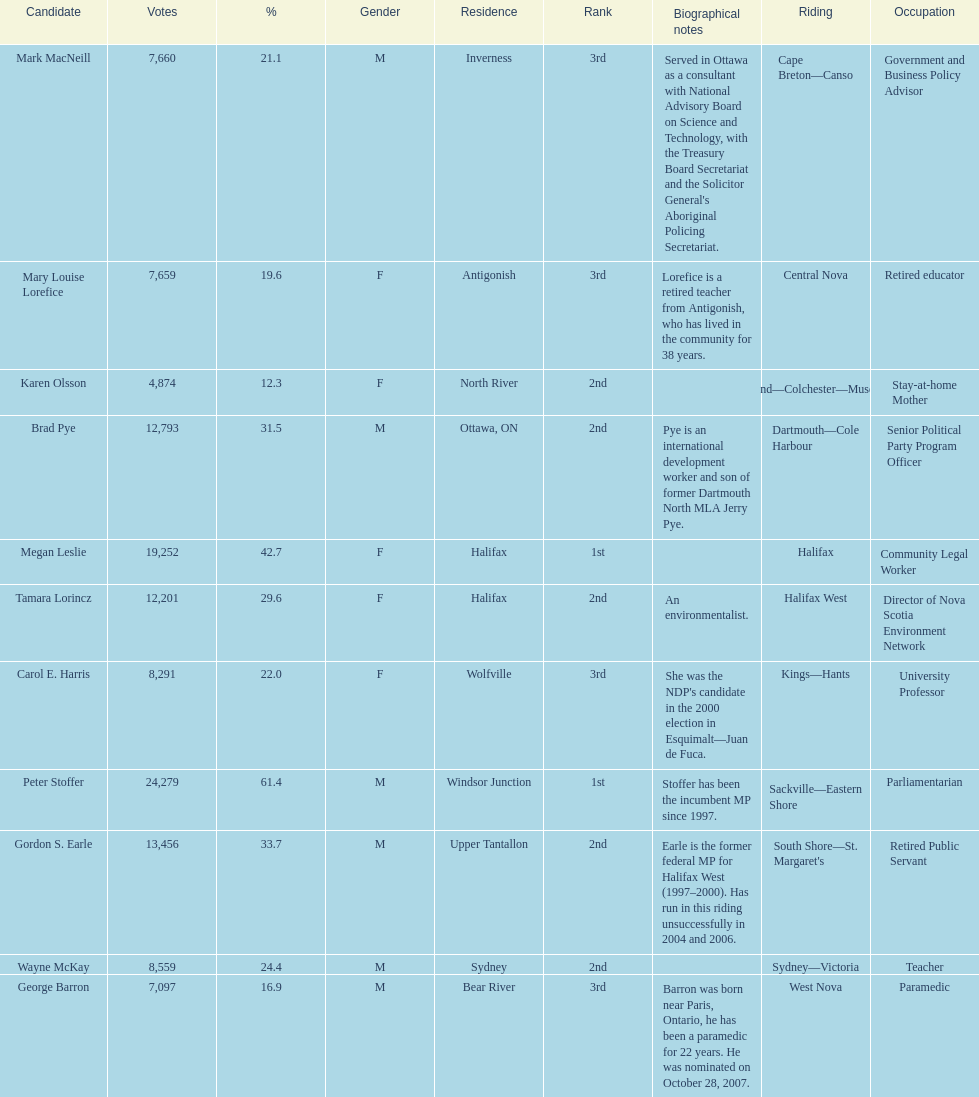What is the number of votes that megan leslie received? 19,252. 